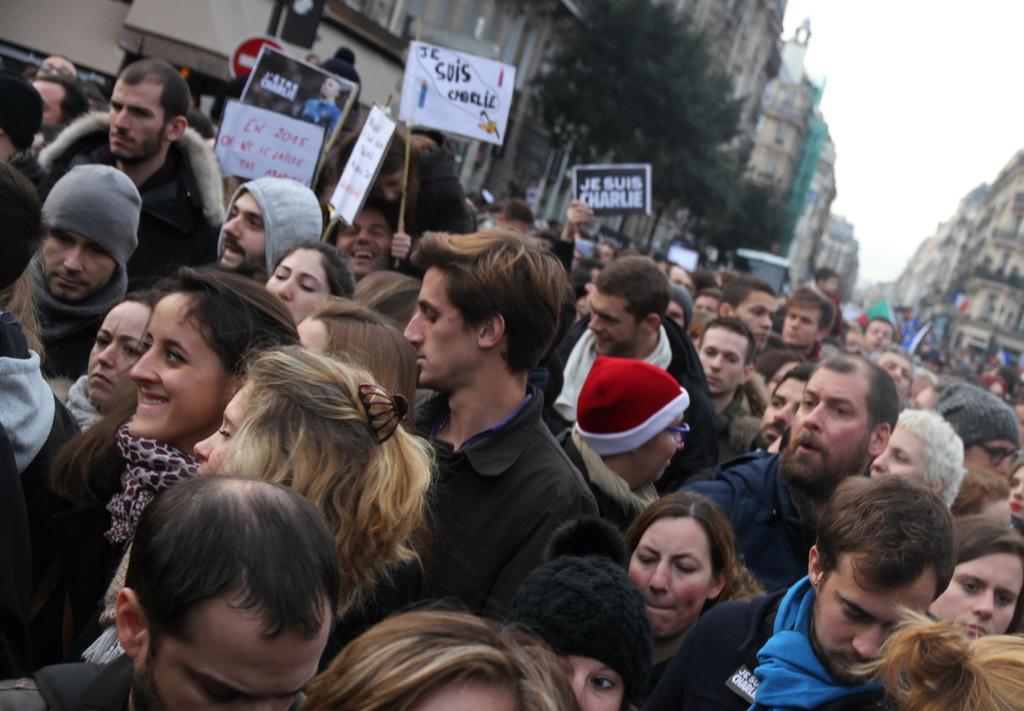Describe this image in one or two sentences. In this image I can see number of people are standing and I can see few of them are wearing jackets and caps. I can also see few people are holding boards and on these boards I can see something is written. In the background I can see few trees, number of buildings, the sky and few vehicles. 